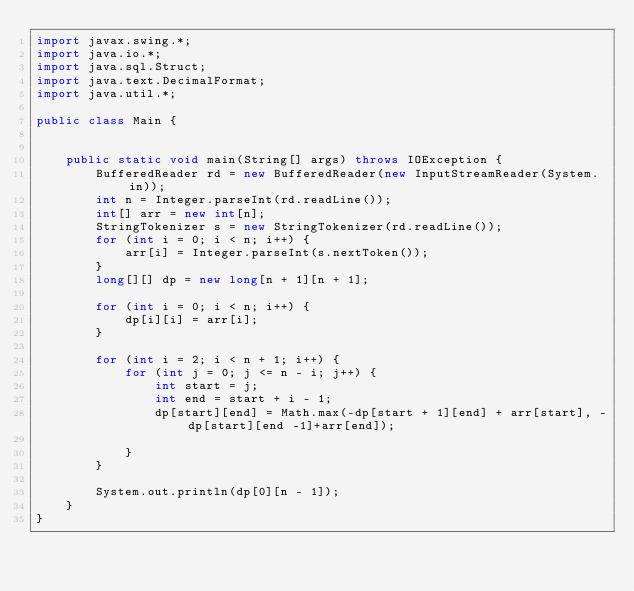<code> <loc_0><loc_0><loc_500><loc_500><_Java_>import javax.swing.*;
import java.io.*;
import java.sql.Struct;
import java.text.DecimalFormat;
import java.util.*;

public class Main {


    public static void main(String[] args) throws IOException {
        BufferedReader rd = new BufferedReader(new InputStreamReader(System.in));
        int n = Integer.parseInt(rd.readLine());
        int[] arr = new int[n];
        StringTokenizer s = new StringTokenizer(rd.readLine());
        for (int i = 0; i < n; i++) {
            arr[i] = Integer.parseInt(s.nextToken());
        }
        long[][] dp = new long[n + 1][n + 1];

        for (int i = 0; i < n; i++) {
            dp[i][i] = arr[i];
        }

        for (int i = 2; i < n + 1; i++) {
            for (int j = 0; j <= n - i; j++) {
                int start = j;
                int end = start + i - 1;
                dp[start][end] = Math.max(-dp[start + 1][end] + arr[start], -dp[start][end -1]+arr[end]);

            }
        }

        System.out.println(dp[0][n - 1]);
    }
}</code> 